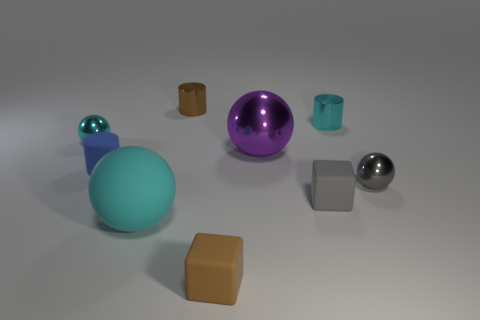Is the number of big balls behind the large cyan sphere greater than the number of tiny matte blocks on the right side of the cyan cylinder?
Provide a short and direct response. Yes. What number of other things are there of the same size as the purple object?
Offer a very short reply. 1. There is another ball that is the same color as the big matte ball; what is its size?
Keep it short and to the point. Small. What material is the tiny cyan object right of the blue cylinder to the left of the large purple shiny object?
Make the answer very short. Metal. Are there any purple shiny things behind the blue matte cylinder?
Make the answer very short. Yes. Are there more large purple spheres in front of the large cyan ball than large metallic objects?
Your response must be concise. No. Are there any tiny things that have the same color as the rubber sphere?
Your answer should be compact. Yes. There is a matte cylinder that is the same size as the brown metallic thing; what color is it?
Offer a very short reply. Blue. There is a tiny cyan shiny thing to the left of the large matte object; is there a gray rubber object on the left side of it?
Make the answer very short. No. What is the material of the cyan ball that is in front of the gray cube?
Ensure brevity in your answer.  Rubber. 